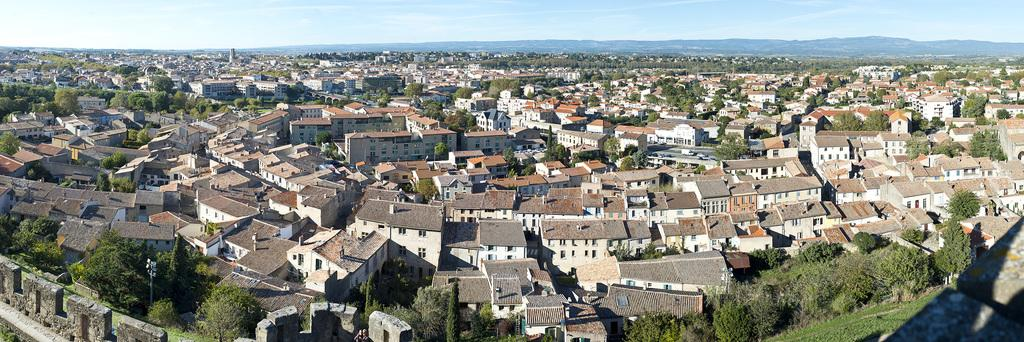What type of structures can be seen in the image? There are houses in the image. What other natural elements are present in the image? There are trees in the image. What can be seen in the distance in the image? The sky is visible in the background of the image. Where is the playground located in the image? There is no playground present in the image. How many chairs can be seen in the image? There are no chairs visible in the image. 